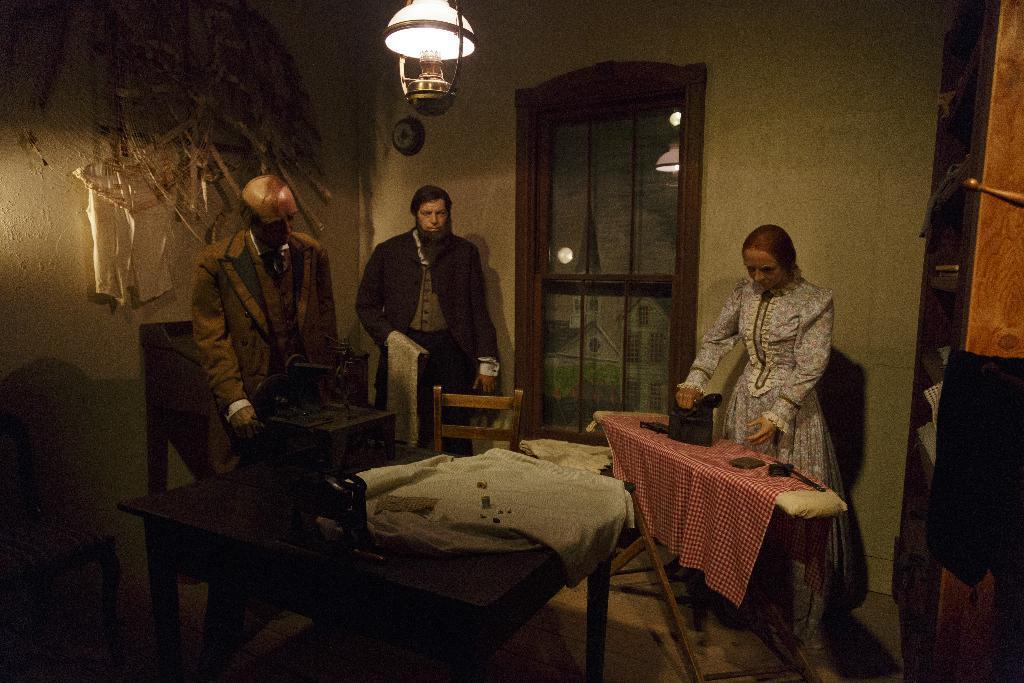Can you describe this image briefly? In this image,there is a table in black color and a white cloth on the table, In the left side there is a white color wall and two mans are standing and in the left side there is a table of white color and there is a iron on the table and a woman is standing and in the background there is a wall of white color and a door,glass door of brown color. 